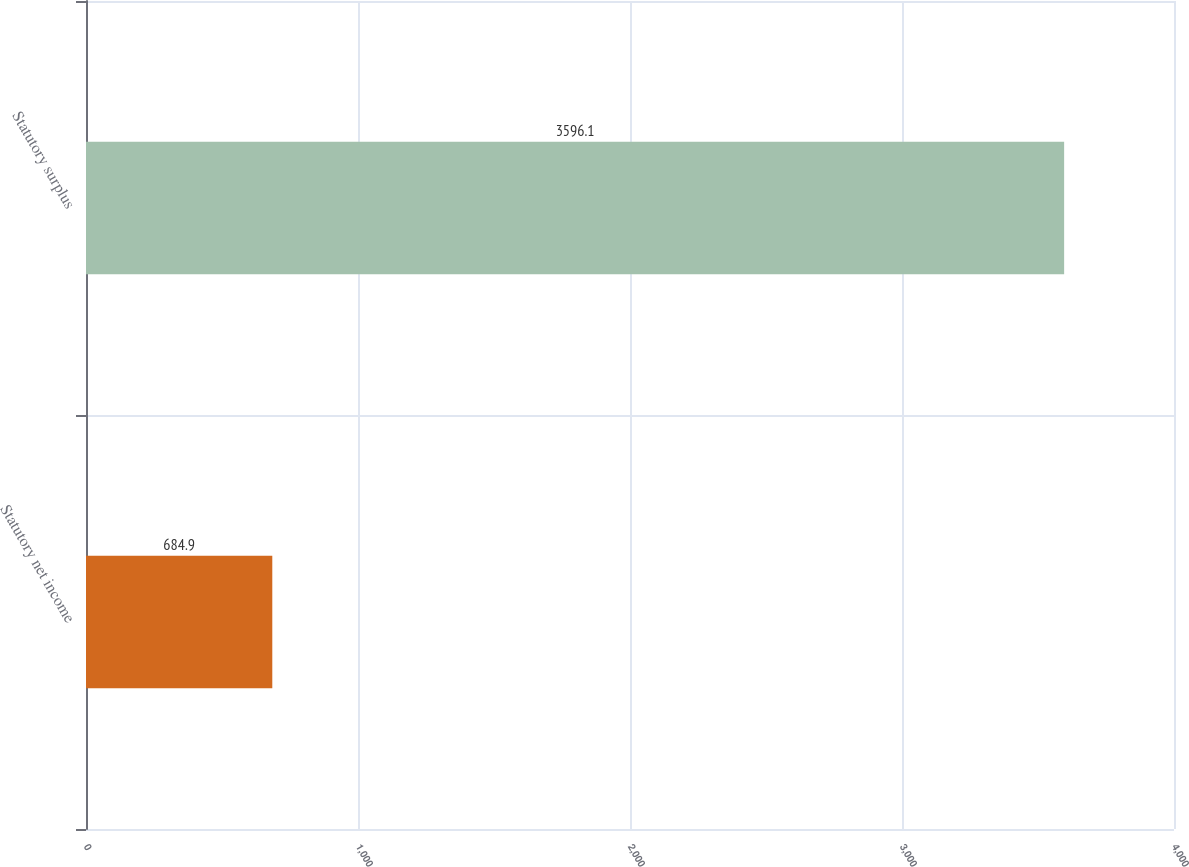<chart> <loc_0><loc_0><loc_500><loc_500><bar_chart><fcel>Statutory net income<fcel>Statutory surplus<nl><fcel>684.9<fcel>3596.1<nl></chart> 